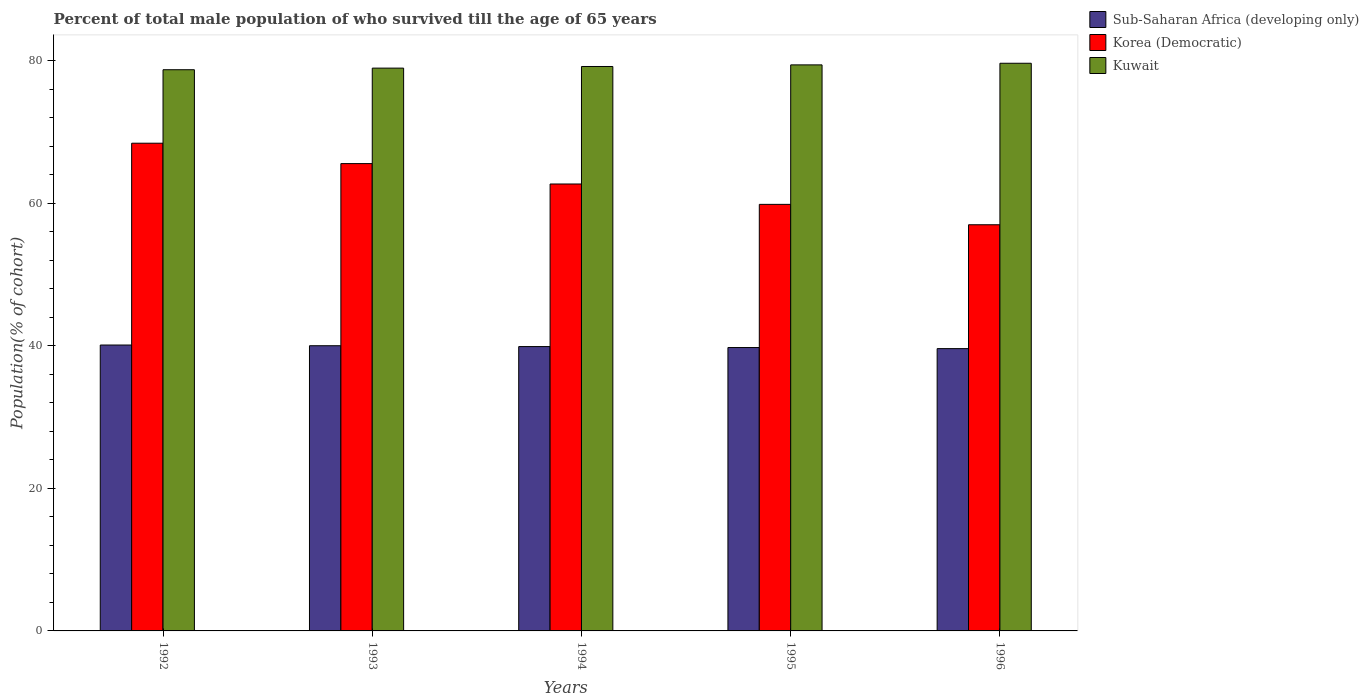How many different coloured bars are there?
Give a very brief answer. 3. Are the number of bars on each tick of the X-axis equal?
Provide a succinct answer. Yes. How many bars are there on the 1st tick from the right?
Keep it short and to the point. 3. What is the percentage of total male population who survived till the age of 65 years in Korea (Democratic) in 1994?
Your response must be concise. 62.71. Across all years, what is the maximum percentage of total male population who survived till the age of 65 years in Sub-Saharan Africa (developing only)?
Offer a very short reply. 40.11. Across all years, what is the minimum percentage of total male population who survived till the age of 65 years in Korea (Democratic)?
Provide a short and direct response. 56.99. In which year was the percentage of total male population who survived till the age of 65 years in Korea (Democratic) maximum?
Make the answer very short. 1992. In which year was the percentage of total male population who survived till the age of 65 years in Kuwait minimum?
Provide a succinct answer. 1992. What is the total percentage of total male population who survived till the age of 65 years in Sub-Saharan Africa (developing only) in the graph?
Your response must be concise. 199.39. What is the difference between the percentage of total male population who survived till the age of 65 years in Korea (Democratic) in 1992 and that in 1996?
Offer a terse response. 11.44. What is the difference between the percentage of total male population who survived till the age of 65 years in Kuwait in 1993 and the percentage of total male population who survived till the age of 65 years in Sub-Saharan Africa (developing only) in 1994?
Provide a short and direct response. 39.07. What is the average percentage of total male population who survived till the age of 65 years in Sub-Saharan Africa (developing only) per year?
Your response must be concise. 39.88. In the year 1992, what is the difference between the percentage of total male population who survived till the age of 65 years in Sub-Saharan Africa (developing only) and percentage of total male population who survived till the age of 65 years in Kuwait?
Keep it short and to the point. -38.62. What is the ratio of the percentage of total male population who survived till the age of 65 years in Korea (Democratic) in 1994 to that in 1995?
Make the answer very short. 1.05. Is the percentage of total male population who survived till the age of 65 years in Korea (Democratic) in 1994 less than that in 1996?
Make the answer very short. No. Is the difference between the percentage of total male population who survived till the age of 65 years in Sub-Saharan Africa (developing only) in 1993 and 1994 greater than the difference between the percentage of total male population who survived till the age of 65 years in Kuwait in 1993 and 1994?
Provide a succinct answer. Yes. What is the difference between the highest and the second highest percentage of total male population who survived till the age of 65 years in Korea (Democratic)?
Your answer should be compact. 2.86. What is the difference between the highest and the lowest percentage of total male population who survived till the age of 65 years in Korea (Democratic)?
Make the answer very short. 11.44. Is the sum of the percentage of total male population who survived till the age of 65 years in Kuwait in 1992 and 1995 greater than the maximum percentage of total male population who survived till the age of 65 years in Korea (Democratic) across all years?
Your response must be concise. Yes. What does the 3rd bar from the left in 1993 represents?
Provide a succinct answer. Kuwait. What does the 1st bar from the right in 1994 represents?
Offer a terse response. Kuwait. Is it the case that in every year, the sum of the percentage of total male population who survived till the age of 65 years in Kuwait and percentage of total male population who survived till the age of 65 years in Sub-Saharan Africa (developing only) is greater than the percentage of total male population who survived till the age of 65 years in Korea (Democratic)?
Make the answer very short. Yes. How many bars are there?
Your answer should be very brief. 15. What is the difference between two consecutive major ticks on the Y-axis?
Make the answer very short. 20. Does the graph contain grids?
Give a very brief answer. No. Where does the legend appear in the graph?
Your answer should be compact. Top right. How many legend labels are there?
Provide a succinct answer. 3. How are the legend labels stacked?
Keep it short and to the point. Vertical. What is the title of the graph?
Provide a succinct answer. Percent of total male population of who survived till the age of 65 years. Does "Malta" appear as one of the legend labels in the graph?
Your answer should be very brief. No. What is the label or title of the Y-axis?
Your answer should be compact. Population(% of cohort). What is the Population(% of cohort) in Sub-Saharan Africa (developing only) in 1992?
Give a very brief answer. 40.11. What is the Population(% of cohort) of Korea (Democratic) in 1992?
Offer a terse response. 68.43. What is the Population(% of cohort) in Kuwait in 1992?
Your response must be concise. 78.74. What is the Population(% of cohort) of Sub-Saharan Africa (developing only) in 1993?
Your answer should be very brief. 40.01. What is the Population(% of cohort) in Korea (Democratic) in 1993?
Your response must be concise. 65.57. What is the Population(% of cohort) in Kuwait in 1993?
Your answer should be compact. 78.96. What is the Population(% of cohort) in Sub-Saharan Africa (developing only) in 1994?
Your answer should be very brief. 39.9. What is the Population(% of cohort) in Korea (Democratic) in 1994?
Offer a very short reply. 62.71. What is the Population(% of cohort) in Kuwait in 1994?
Give a very brief answer. 79.19. What is the Population(% of cohort) of Sub-Saharan Africa (developing only) in 1995?
Offer a very short reply. 39.76. What is the Population(% of cohort) in Korea (Democratic) in 1995?
Make the answer very short. 59.85. What is the Population(% of cohort) of Kuwait in 1995?
Provide a succinct answer. 79.42. What is the Population(% of cohort) in Sub-Saharan Africa (developing only) in 1996?
Keep it short and to the point. 39.61. What is the Population(% of cohort) of Korea (Democratic) in 1996?
Ensure brevity in your answer.  56.99. What is the Population(% of cohort) of Kuwait in 1996?
Ensure brevity in your answer.  79.64. Across all years, what is the maximum Population(% of cohort) of Sub-Saharan Africa (developing only)?
Make the answer very short. 40.11. Across all years, what is the maximum Population(% of cohort) of Korea (Democratic)?
Give a very brief answer. 68.43. Across all years, what is the maximum Population(% of cohort) in Kuwait?
Provide a short and direct response. 79.64. Across all years, what is the minimum Population(% of cohort) of Sub-Saharan Africa (developing only)?
Offer a very short reply. 39.61. Across all years, what is the minimum Population(% of cohort) of Korea (Democratic)?
Ensure brevity in your answer.  56.99. Across all years, what is the minimum Population(% of cohort) in Kuwait?
Keep it short and to the point. 78.74. What is the total Population(% of cohort) of Sub-Saharan Africa (developing only) in the graph?
Provide a succinct answer. 199.39. What is the total Population(% of cohort) in Korea (Democratic) in the graph?
Give a very brief answer. 313.53. What is the total Population(% of cohort) of Kuwait in the graph?
Give a very brief answer. 395.95. What is the difference between the Population(% of cohort) in Sub-Saharan Africa (developing only) in 1992 and that in 1993?
Your answer should be compact. 0.1. What is the difference between the Population(% of cohort) of Korea (Democratic) in 1992 and that in 1993?
Offer a terse response. 2.86. What is the difference between the Population(% of cohort) of Kuwait in 1992 and that in 1993?
Provide a short and direct response. -0.23. What is the difference between the Population(% of cohort) in Sub-Saharan Africa (developing only) in 1992 and that in 1994?
Your answer should be compact. 0.22. What is the difference between the Population(% of cohort) in Korea (Democratic) in 1992 and that in 1994?
Offer a terse response. 5.72. What is the difference between the Population(% of cohort) of Kuwait in 1992 and that in 1994?
Offer a very short reply. -0.45. What is the difference between the Population(% of cohort) of Sub-Saharan Africa (developing only) in 1992 and that in 1995?
Your answer should be compact. 0.35. What is the difference between the Population(% of cohort) in Korea (Democratic) in 1992 and that in 1995?
Your answer should be very brief. 8.58. What is the difference between the Population(% of cohort) in Kuwait in 1992 and that in 1995?
Your response must be concise. -0.68. What is the difference between the Population(% of cohort) of Sub-Saharan Africa (developing only) in 1992 and that in 1996?
Give a very brief answer. 0.5. What is the difference between the Population(% of cohort) of Korea (Democratic) in 1992 and that in 1996?
Your answer should be compact. 11.44. What is the difference between the Population(% of cohort) of Kuwait in 1992 and that in 1996?
Your answer should be compact. -0.91. What is the difference between the Population(% of cohort) of Sub-Saharan Africa (developing only) in 1993 and that in 1994?
Your answer should be very brief. 0.12. What is the difference between the Population(% of cohort) in Korea (Democratic) in 1993 and that in 1994?
Give a very brief answer. 2.86. What is the difference between the Population(% of cohort) of Kuwait in 1993 and that in 1994?
Provide a short and direct response. -0.23. What is the difference between the Population(% of cohort) in Sub-Saharan Africa (developing only) in 1993 and that in 1995?
Your answer should be very brief. 0.25. What is the difference between the Population(% of cohort) of Korea (Democratic) in 1993 and that in 1995?
Offer a very short reply. 5.72. What is the difference between the Population(% of cohort) of Kuwait in 1993 and that in 1995?
Offer a very short reply. -0.45. What is the difference between the Population(% of cohort) in Sub-Saharan Africa (developing only) in 1993 and that in 1996?
Your answer should be very brief. 0.4. What is the difference between the Population(% of cohort) of Korea (Democratic) in 1993 and that in 1996?
Keep it short and to the point. 8.58. What is the difference between the Population(% of cohort) of Kuwait in 1993 and that in 1996?
Ensure brevity in your answer.  -0.68. What is the difference between the Population(% of cohort) in Sub-Saharan Africa (developing only) in 1994 and that in 1995?
Provide a short and direct response. 0.14. What is the difference between the Population(% of cohort) of Korea (Democratic) in 1994 and that in 1995?
Provide a short and direct response. 2.86. What is the difference between the Population(% of cohort) of Kuwait in 1994 and that in 1995?
Give a very brief answer. -0.23. What is the difference between the Population(% of cohort) of Sub-Saharan Africa (developing only) in 1994 and that in 1996?
Provide a short and direct response. 0.29. What is the difference between the Population(% of cohort) in Korea (Democratic) in 1994 and that in 1996?
Give a very brief answer. 5.72. What is the difference between the Population(% of cohort) in Kuwait in 1994 and that in 1996?
Your answer should be very brief. -0.45. What is the difference between the Population(% of cohort) of Sub-Saharan Africa (developing only) in 1995 and that in 1996?
Your answer should be compact. 0.15. What is the difference between the Population(% of cohort) of Korea (Democratic) in 1995 and that in 1996?
Offer a terse response. 2.86. What is the difference between the Population(% of cohort) of Kuwait in 1995 and that in 1996?
Keep it short and to the point. -0.23. What is the difference between the Population(% of cohort) of Sub-Saharan Africa (developing only) in 1992 and the Population(% of cohort) of Korea (Democratic) in 1993?
Your answer should be very brief. -25.45. What is the difference between the Population(% of cohort) of Sub-Saharan Africa (developing only) in 1992 and the Population(% of cohort) of Kuwait in 1993?
Keep it short and to the point. -38.85. What is the difference between the Population(% of cohort) of Korea (Democratic) in 1992 and the Population(% of cohort) of Kuwait in 1993?
Make the answer very short. -10.54. What is the difference between the Population(% of cohort) in Sub-Saharan Africa (developing only) in 1992 and the Population(% of cohort) in Korea (Democratic) in 1994?
Provide a succinct answer. -22.59. What is the difference between the Population(% of cohort) of Sub-Saharan Africa (developing only) in 1992 and the Population(% of cohort) of Kuwait in 1994?
Your answer should be compact. -39.08. What is the difference between the Population(% of cohort) of Korea (Democratic) in 1992 and the Population(% of cohort) of Kuwait in 1994?
Make the answer very short. -10.76. What is the difference between the Population(% of cohort) of Sub-Saharan Africa (developing only) in 1992 and the Population(% of cohort) of Korea (Democratic) in 1995?
Your response must be concise. -19.73. What is the difference between the Population(% of cohort) of Sub-Saharan Africa (developing only) in 1992 and the Population(% of cohort) of Kuwait in 1995?
Provide a succinct answer. -39.3. What is the difference between the Population(% of cohort) in Korea (Democratic) in 1992 and the Population(% of cohort) in Kuwait in 1995?
Ensure brevity in your answer.  -10.99. What is the difference between the Population(% of cohort) in Sub-Saharan Africa (developing only) in 1992 and the Population(% of cohort) in Korea (Democratic) in 1996?
Provide a short and direct response. -16.87. What is the difference between the Population(% of cohort) in Sub-Saharan Africa (developing only) in 1992 and the Population(% of cohort) in Kuwait in 1996?
Make the answer very short. -39.53. What is the difference between the Population(% of cohort) of Korea (Democratic) in 1992 and the Population(% of cohort) of Kuwait in 1996?
Offer a terse response. -11.22. What is the difference between the Population(% of cohort) of Sub-Saharan Africa (developing only) in 1993 and the Population(% of cohort) of Korea (Democratic) in 1994?
Keep it short and to the point. -22.69. What is the difference between the Population(% of cohort) of Sub-Saharan Africa (developing only) in 1993 and the Population(% of cohort) of Kuwait in 1994?
Ensure brevity in your answer.  -39.18. What is the difference between the Population(% of cohort) of Korea (Democratic) in 1993 and the Population(% of cohort) of Kuwait in 1994?
Ensure brevity in your answer.  -13.62. What is the difference between the Population(% of cohort) of Sub-Saharan Africa (developing only) in 1993 and the Population(% of cohort) of Korea (Democratic) in 1995?
Offer a very short reply. -19.83. What is the difference between the Population(% of cohort) of Sub-Saharan Africa (developing only) in 1993 and the Population(% of cohort) of Kuwait in 1995?
Your answer should be compact. -39.4. What is the difference between the Population(% of cohort) in Korea (Democratic) in 1993 and the Population(% of cohort) in Kuwait in 1995?
Your answer should be very brief. -13.85. What is the difference between the Population(% of cohort) of Sub-Saharan Africa (developing only) in 1993 and the Population(% of cohort) of Korea (Democratic) in 1996?
Your answer should be compact. -16.97. What is the difference between the Population(% of cohort) of Sub-Saharan Africa (developing only) in 1993 and the Population(% of cohort) of Kuwait in 1996?
Ensure brevity in your answer.  -39.63. What is the difference between the Population(% of cohort) in Korea (Democratic) in 1993 and the Population(% of cohort) in Kuwait in 1996?
Keep it short and to the point. -14.08. What is the difference between the Population(% of cohort) of Sub-Saharan Africa (developing only) in 1994 and the Population(% of cohort) of Korea (Democratic) in 1995?
Provide a short and direct response. -19.95. What is the difference between the Population(% of cohort) of Sub-Saharan Africa (developing only) in 1994 and the Population(% of cohort) of Kuwait in 1995?
Your response must be concise. -39.52. What is the difference between the Population(% of cohort) of Korea (Democratic) in 1994 and the Population(% of cohort) of Kuwait in 1995?
Give a very brief answer. -16.71. What is the difference between the Population(% of cohort) in Sub-Saharan Africa (developing only) in 1994 and the Population(% of cohort) in Korea (Democratic) in 1996?
Keep it short and to the point. -17.09. What is the difference between the Population(% of cohort) in Sub-Saharan Africa (developing only) in 1994 and the Population(% of cohort) in Kuwait in 1996?
Your response must be concise. -39.75. What is the difference between the Population(% of cohort) of Korea (Democratic) in 1994 and the Population(% of cohort) of Kuwait in 1996?
Provide a succinct answer. -16.94. What is the difference between the Population(% of cohort) in Sub-Saharan Africa (developing only) in 1995 and the Population(% of cohort) in Korea (Democratic) in 1996?
Offer a terse response. -17.23. What is the difference between the Population(% of cohort) of Sub-Saharan Africa (developing only) in 1995 and the Population(% of cohort) of Kuwait in 1996?
Provide a succinct answer. -39.89. What is the difference between the Population(% of cohort) of Korea (Democratic) in 1995 and the Population(% of cohort) of Kuwait in 1996?
Your answer should be very brief. -19.8. What is the average Population(% of cohort) of Sub-Saharan Africa (developing only) per year?
Offer a terse response. 39.88. What is the average Population(% of cohort) in Korea (Democratic) per year?
Provide a short and direct response. 62.71. What is the average Population(% of cohort) of Kuwait per year?
Give a very brief answer. 79.19. In the year 1992, what is the difference between the Population(% of cohort) in Sub-Saharan Africa (developing only) and Population(% of cohort) in Korea (Democratic)?
Provide a short and direct response. -28.31. In the year 1992, what is the difference between the Population(% of cohort) of Sub-Saharan Africa (developing only) and Population(% of cohort) of Kuwait?
Offer a terse response. -38.62. In the year 1992, what is the difference between the Population(% of cohort) of Korea (Democratic) and Population(% of cohort) of Kuwait?
Your response must be concise. -10.31. In the year 1993, what is the difference between the Population(% of cohort) in Sub-Saharan Africa (developing only) and Population(% of cohort) in Korea (Democratic)?
Your answer should be very brief. -25.55. In the year 1993, what is the difference between the Population(% of cohort) of Sub-Saharan Africa (developing only) and Population(% of cohort) of Kuwait?
Keep it short and to the point. -38.95. In the year 1993, what is the difference between the Population(% of cohort) in Korea (Democratic) and Population(% of cohort) in Kuwait?
Make the answer very short. -13.4. In the year 1994, what is the difference between the Population(% of cohort) of Sub-Saharan Africa (developing only) and Population(% of cohort) of Korea (Democratic)?
Your answer should be very brief. -22.81. In the year 1994, what is the difference between the Population(% of cohort) of Sub-Saharan Africa (developing only) and Population(% of cohort) of Kuwait?
Make the answer very short. -39.29. In the year 1994, what is the difference between the Population(% of cohort) of Korea (Democratic) and Population(% of cohort) of Kuwait?
Your answer should be very brief. -16.48. In the year 1995, what is the difference between the Population(% of cohort) of Sub-Saharan Africa (developing only) and Population(% of cohort) of Korea (Democratic)?
Offer a very short reply. -20.09. In the year 1995, what is the difference between the Population(% of cohort) of Sub-Saharan Africa (developing only) and Population(% of cohort) of Kuwait?
Give a very brief answer. -39.66. In the year 1995, what is the difference between the Population(% of cohort) in Korea (Democratic) and Population(% of cohort) in Kuwait?
Provide a short and direct response. -19.57. In the year 1996, what is the difference between the Population(% of cohort) in Sub-Saharan Africa (developing only) and Population(% of cohort) in Korea (Democratic)?
Keep it short and to the point. -17.38. In the year 1996, what is the difference between the Population(% of cohort) in Sub-Saharan Africa (developing only) and Population(% of cohort) in Kuwait?
Keep it short and to the point. -40.04. In the year 1996, what is the difference between the Population(% of cohort) of Korea (Democratic) and Population(% of cohort) of Kuwait?
Keep it short and to the point. -22.66. What is the ratio of the Population(% of cohort) in Sub-Saharan Africa (developing only) in 1992 to that in 1993?
Offer a terse response. 1. What is the ratio of the Population(% of cohort) in Korea (Democratic) in 1992 to that in 1993?
Offer a terse response. 1.04. What is the ratio of the Population(% of cohort) of Sub-Saharan Africa (developing only) in 1992 to that in 1994?
Your answer should be compact. 1.01. What is the ratio of the Population(% of cohort) of Korea (Democratic) in 1992 to that in 1994?
Give a very brief answer. 1.09. What is the ratio of the Population(% of cohort) of Sub-Saharan Africa (developing only) in 1992 to that in 1995?
Keep it short and to the point. 1.01. What is the ratio of the Population(% of cohort) in Korea (Democratic) in 1992 to that in 1995?
Make the answer very short. 1.14. What is the ratio of the Population(% of cohort) in Kuwait in 1992 to that in 1995?
Your answer should be very brief. 0.99. What is the ratio of the Population(% of cohort) in Sub-Saharan Africa (developing only) in 1992 to that in 1996?
Give a very brief answer. 1.01. What is the ratio of the Population(% of cohort) in Korea (Democratic) in 1992 to that in 1996?
Make the answer very short. 1.2. What is the ratio of the Population(% of cohort) in Kuwait in 1992 to that in 1996?
Your answer should be compact. 0.99. What is the ratio of the Population(% of cohort) in Sub-Saharan Africa (developing only) in 1993 to that in 1994?
Your answer should be compact. 1. What is the ratio of the Population(% of cohort) in Korea (Democratic) in 1993 to that in 1994?
Make the answer very short. 1.05. What is the ratio of the Population(% of cohort) in Sub-Saharan Africa (developing only) in 1993 to that in 1995?
Offer a terse response. 1.01. What is the ratio of the Population(% of cohort) of Korea (Democratic) in 1993 to that in 1995?
Make the answer very short. 1.1. What is the ratio of the Population(% of cohort) in Kuwait in 1993 to that in 1995?
Offer a terse response. 0.99. What is the ratio of the Population(% of cohort) of Sub-Saharan Africa (developing only) in 1993 to that in 1996?
Your response must be concise. 1.01. What is the ratio of the Population(% of cohort) in Korea (Democratic) in 1993 to that in 1996?
Your answer should be compact. 1.15. What is the ratio of the Population(% of cohort) in Sub-Saharan Africa (developing only) in 1994 to that in 1995?
Ensure brevity in your answer.  1. What is the ratio of the Population(% of cohort) in Korea (Democratic) in 1994 to that in 1995?
Offer a terse response. 1.05. What is the ratio of the Population(% of cohort) in Kuwait in 1994 to that in 1995?
Your response must be concise. 1. What is the ratio of the Population(% of cohort) of Sub-Saharan Africa (developing only) in 1994 to that in 1996?
Ensure brevity in your answer.  1.01. What is the ratio of the Population(% of cohort) of Korea (Democratic) in 1994 to that in 1996?
Your response must be concise. 1.1. What is the ratio of the Population(% of cohort) in Sub-Saharan Africa (developing only) in 1995 to that in 1996?
Offer a very short reply. 1. What is the ratio of the Population(% of cohort) in Korea (Democratic) in 1995 to that in 1996?
Ensure brevity in your answer.  1.05. What is the ratio of the Population(% of cohort) in Kuwait in 1995 to that in 1996?
Your answer should be compact. 1. What is the difference between the highest and the second highest Population(% of cohort) of Sub-Saharan Africa (developing only)?
Keep it short and to the point. 0.1. What is the difference between the highest and the second highest Population(% of cohort) of Korea (Democratic)?
Your answer should be very brief. 2.86. What is the difference between the highest and the second highest Population(% of cohort) in Kuwait?
Ensure brevity in your answer.  0.23. What is the difference between the highest and the lowest Population(% of cohort) in Sub-Saharan Africa (developing only)?
Keep it short and to the point. 0.5. What is the difference between the highest and the lowest Population(% of cohort) in Korea (Democratic)?
Your answer should be very brief. 11.44. What is the difference between the highest and the lowest Population(% of cohort) of Kuwait?
Your response must be concise. 0.91. 